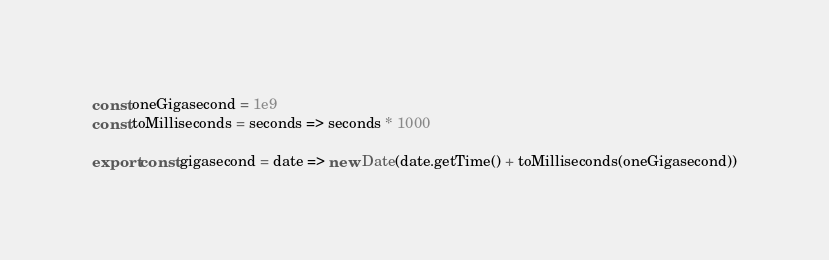<code> <loc_0><loc_0><loc_500><loc_500><_JavaScript_>const oneGigasecond = 1e9
const toMilliseconds = seconds => seconds * 1000

export const gigasecond = date => new Date(date.getTime() + toMilliseconds(oneGigasecond))
</code> 